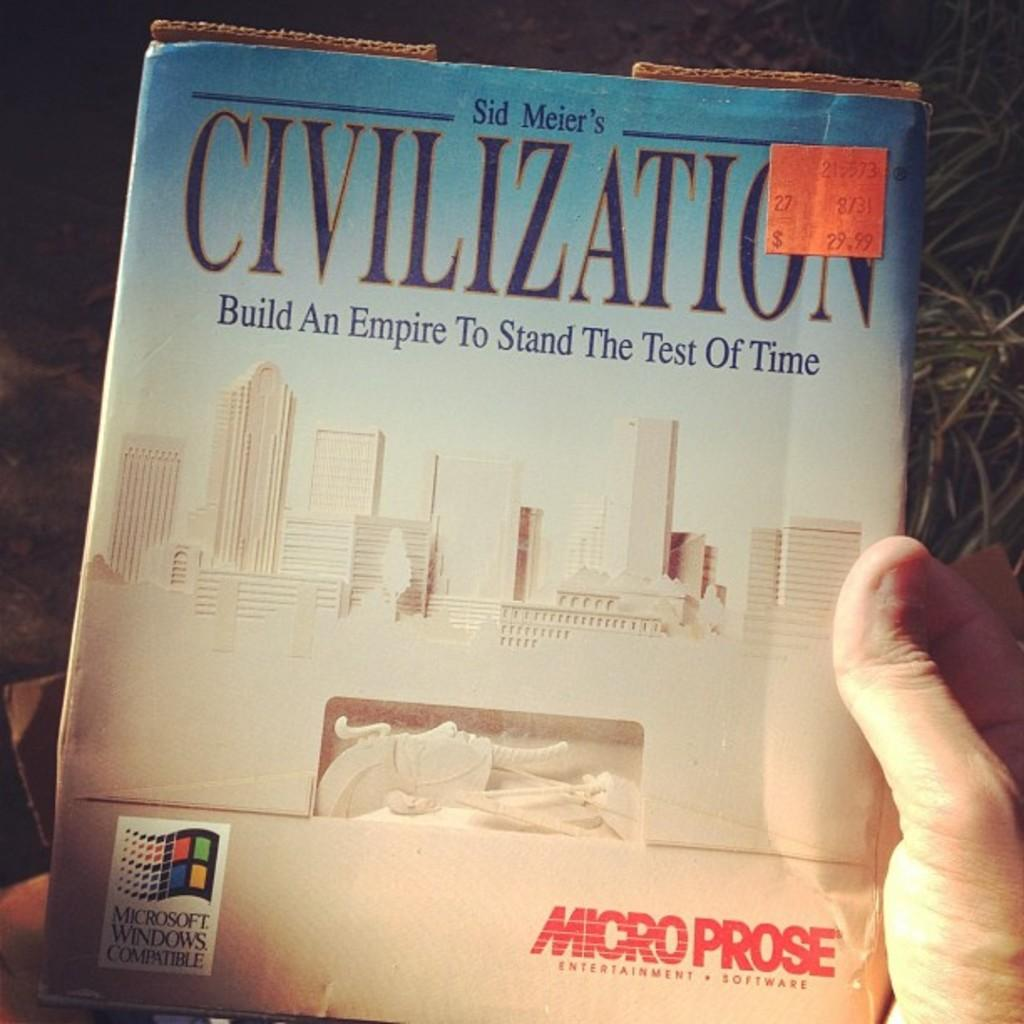<image>
Render a clear and concise summary of the photo. A cover of Civilization that is by someone called Sid Meier. 